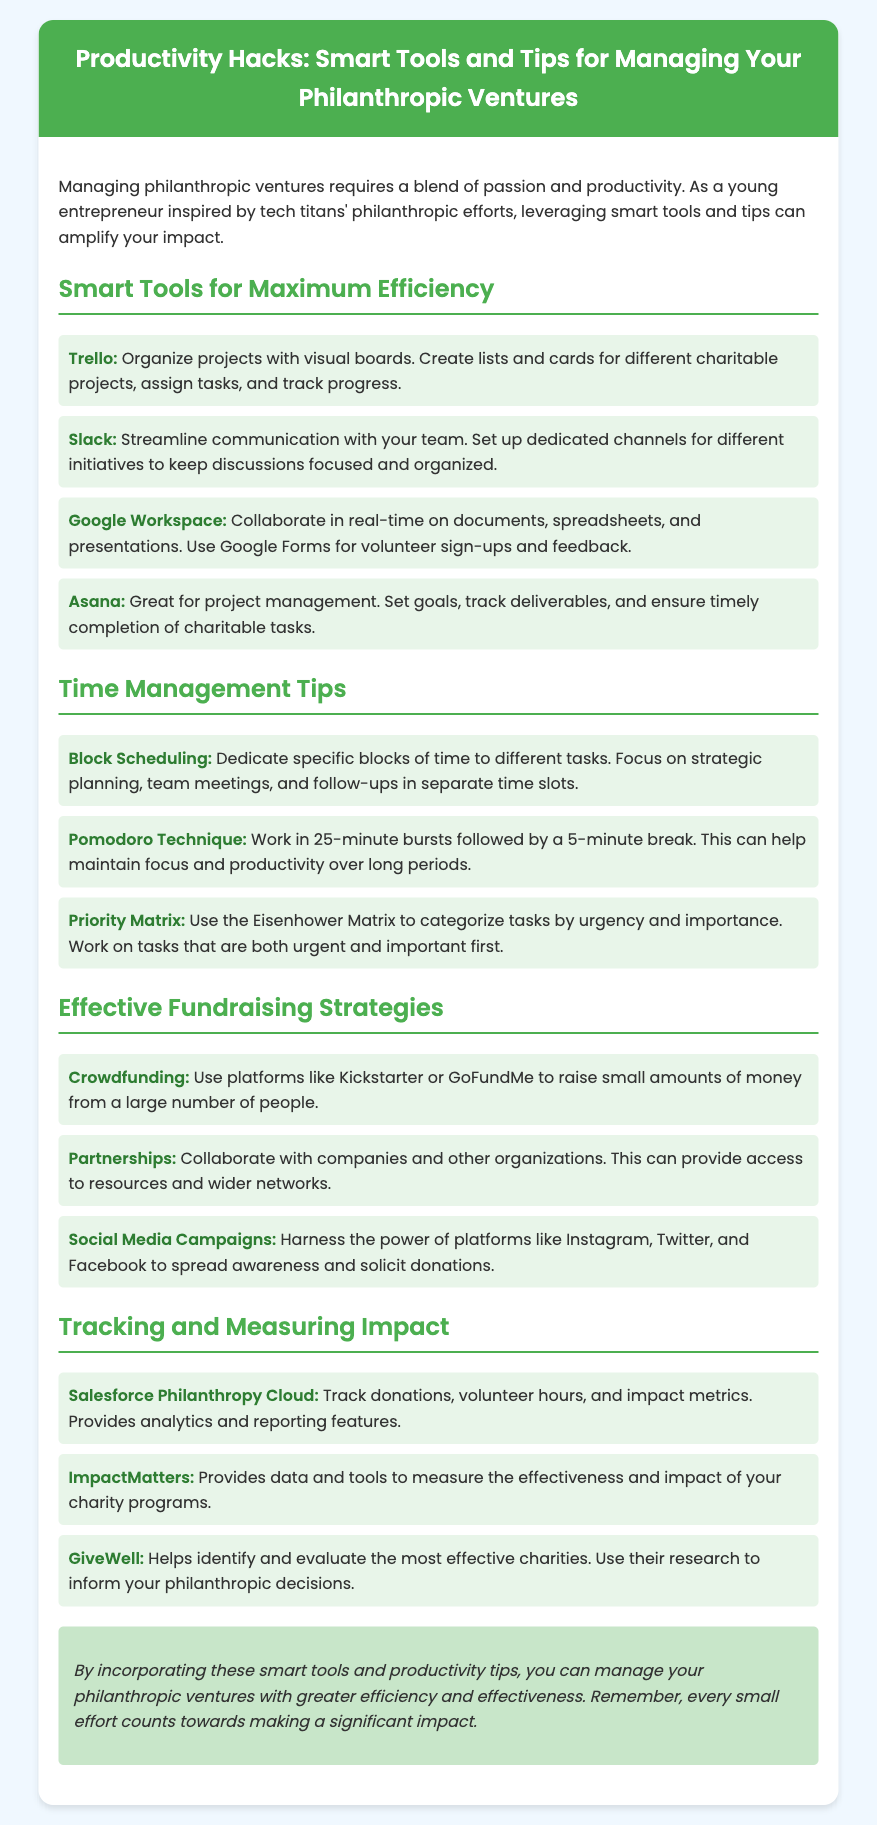What is the title of the document? The title of the document is stated in the header section of the recipe card.
Answer: Productivity Hacks: Smart Tools and Tips for Managing Your Philanthropic Ventures How many smart tools are listed? The number of smart tools can be found by counting the items in the list under the section titled Smart Tools for Maximum Efficiency.
Answer: Four Name one tool used for project management. A specific tool for project management is mentioned in the corresponding section of the document.
Answer: Asana What technique involves working in 25-minute bursts? This technique is identified under the Time Management Tips section and specified in relation to productivity.
Answer: Pomodoro Technique Which social media platform is mentioned for fundraising campaigns? The document provides an example of a platform used in social media campaigns under Effective Fundraising Strategies.
Answer: Instagram What is the focus of the conclusion? The conclusion summarizes a key theme mentioned throughout the document regarding managing philanthropic ventures.
Answer: Efficiency and effectiveness How many time management tips are provided? The total count of tips can be determined by counting the items listed under the Time Management Tips section.
Answer: Three Name a tool for tracking donations. The document lists specific tools for measuring impact, one of which is for tracking donations.
Answer: Salesforce Philanthropy Cloud 